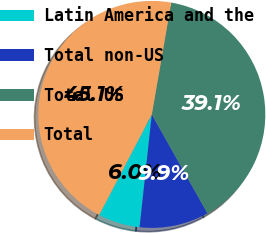<chart> <loc_0><loc_0><loc_500><loc_500><pie_chart><fcel>Latin America and the<fcel>Total non-US<fcel>Total US<fcel>Total<nl><fcel>5.96%<fcel>9.87%<fcel>39.1%<fcel>45.06%<nl></chart> 